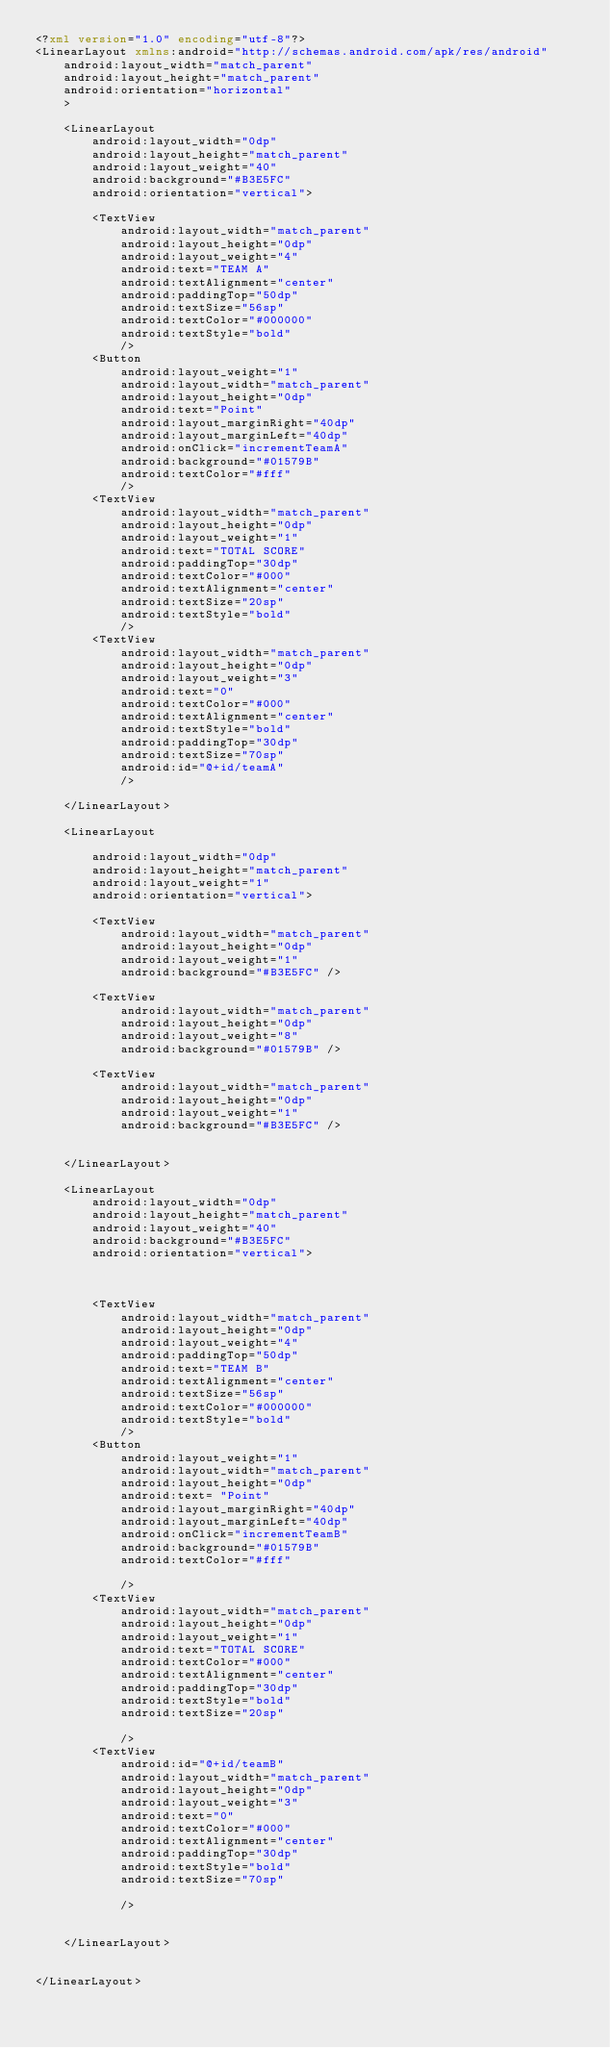<code> <loc_0><loc_0><loc_500><loc_500><_XML_><?xml version="1.0" encoding="utf-8"?>
<LinearLayout xmlns:android="http://schemas.android.com/apk/res/android"
    android:layout_width="match_parent"
    android:layout_height="match_parent"
    android:orientation="horizontal"
    >

    <LinearLayout
        android:layout_width="0dp"
        android:layout_height="match_parent"
        android:layout_weight="40"
        android:background="#B3E5FC"
        android:orientation="vertical">

        <TextView
            android:layout_width="match_parent"
            android:layout_height="0dp"
            android:layout_weight="4"
            android:text="TEAM A"
            android:textAlignment="center"
            android:paddingTop="50dp"
            android:textSize="56sp"
            android:textColor="#000000"
            android:textStyle="bold"
            />
        <Button
            android:layout_weight="1"
            android:layout_width="match_parent"
            android:layout_height="0dp"
            android:text="Point"
            android:layout_marginRight="40dp"
            android:layout_marginLeft="40dp"
            android:onClick="incrementTeamA"
            android:background="#01579B"
            android:textColor="#fff"
            />
        <TextView
            android:layout_width="match_parent"
            android:layout_height="0dp"
            android:layout_weight="1"
            android:text="TOTAL SCORE"
            android:paddingTop="30dp"
            android:textColor="#000"
            android:textAlignment="center"
            android:textSize="20sp"
            android:textStyle="bold"
            />
        <TextView
            android:layout_width="match_parent"
            android:layout_height="0dp"
            android:layout_weight="3"
            android:text="0"
            android:textColor="#000"
            android:textAlignment="center"
            android:textStyle="bold"
            android:paddingTop="30dp"
            android:textSize="70sp"
            android:id="@+id/teamA"
            />

    </LinearLayout>

    <LinearLayout

        android:layout_width="0dp"
        android:layout_height="match_parent"
        android:layout_weight="1"
        android:orientation="vertical">

        <TextView
            android:layout_width="match_parent"
            android:layout_height="0dp"
            android:layout_weight="1"
            android:background="#B3E5FC" />

        <TextView
            android:layout_width="match_parent"
            android:layout_height="0dp"
            android:layout_weight="8"
            android:background="#01579B" />

        <TextView
            android:layout_width="match_parent"
            android:layout_height="0dp"
            android:layout_weight="1"
            android:background="#B3E5FC" />


    </LinearLayout>

    <LinearLayout
        android:layout_width="0dp"
        android:layout_height="match_parent"
        android:layout_weight="40"
        android:background="#B3E5FC"
        android:orientation="vertical">



        <TextView
            android:layout_width="match_parent"
            android:layout_height="0dp"
            android:layout_weight="4"
            android:paddingTop="50dp"
            android:text="TEAM B"
            android:textAlignment="center"
            android:textSize="56sp"
            android:textColor="#000000"
            android:textStyle="bold"
            />
        <Button
            android:layout_weight="1"
            android:layout_width="match_parent"
            android:layout_height="0dp"
            android:text= "Point"
            android:layout_marginRight="40dp"
            android:layout_marginLeft="40dp"
            android:onClick="incrementTeamB"
            android:background="#01579B"
            android:textColor="#fff"

            />
        <TextView
            android:layout_width="match_parent"
            android:layout_height="0dp"
            android:layout_weight="1"
            android:text="TOTAL SCORE"
            android:textColor="#000"
            android:textAlignment="center"
            android:paddingTop="30dp"
            android:textStyle="bold"
            android:textSize="20sp"

            />
        <TextView
            android:id="@+id/teamB"
            android:layout_width="match_parent"
            android:layout_height="0dp"
            android:layout_weight="3"
            android:text="0"
            android:textColor="#000"
            android:textAlignment="center"
            android:paddingTop="30dp"
            android:textStyle="bold"
            android:textSize="70sp"

            />


    </LinearLayout>


</LinearLayout>
</code> 